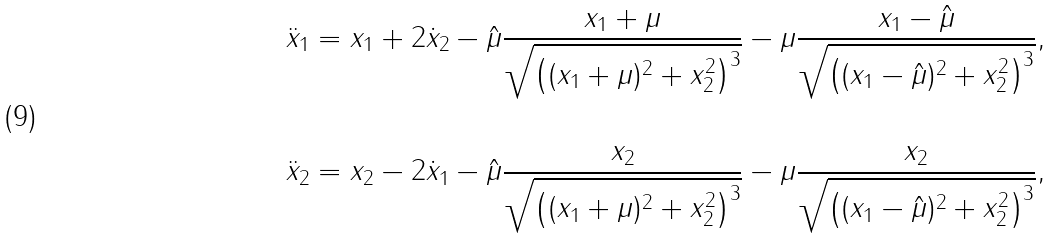Convert formula to latex. <formula><loc_0><loc_0><loc_500><loc_500>\ddot { x } _ { 1 } & = x _ { 1 } + 2 \dot { x } _ { 2 } - \hat { \mu } \frac { x _ { 1 } + \mu } { \sqrt { \left ( ( x _ { 1 } + \mu ) ^ { 2 } + x _ { 2 } ^ { 2 } \right ) ^ { 3 } } } - \mu \frac { x _ { 1 } - \hat { \mu } } { \sqrt { \left ( ( x _ { 1 } - \hat { \mu } ) ^ { 2 } + x _ { 2 } ^ { 2 } \right ) ^ { 3 } } } , \\ \\ \ddot { x } _ { 2 } & = x _ { 2 } - 2 \dot { x } _ { 1 } - \hat { \mu } \frac { x _ { 2 } } { \sqrt { \left ( ( x _ { 1 } + \mu ) ^ { 2 } + x _ { 2 } ^ { 2 } \right ) ^ { 3 } } } - \mu \frac { x _ { 2 } } { \sqrt { \left ( ( x _ { 1 } - \hat { \mu } ) ^ { 2 } + x _ { 2 } ^ { 2 } \right ) ^ { 3 } } } ,</formula> 